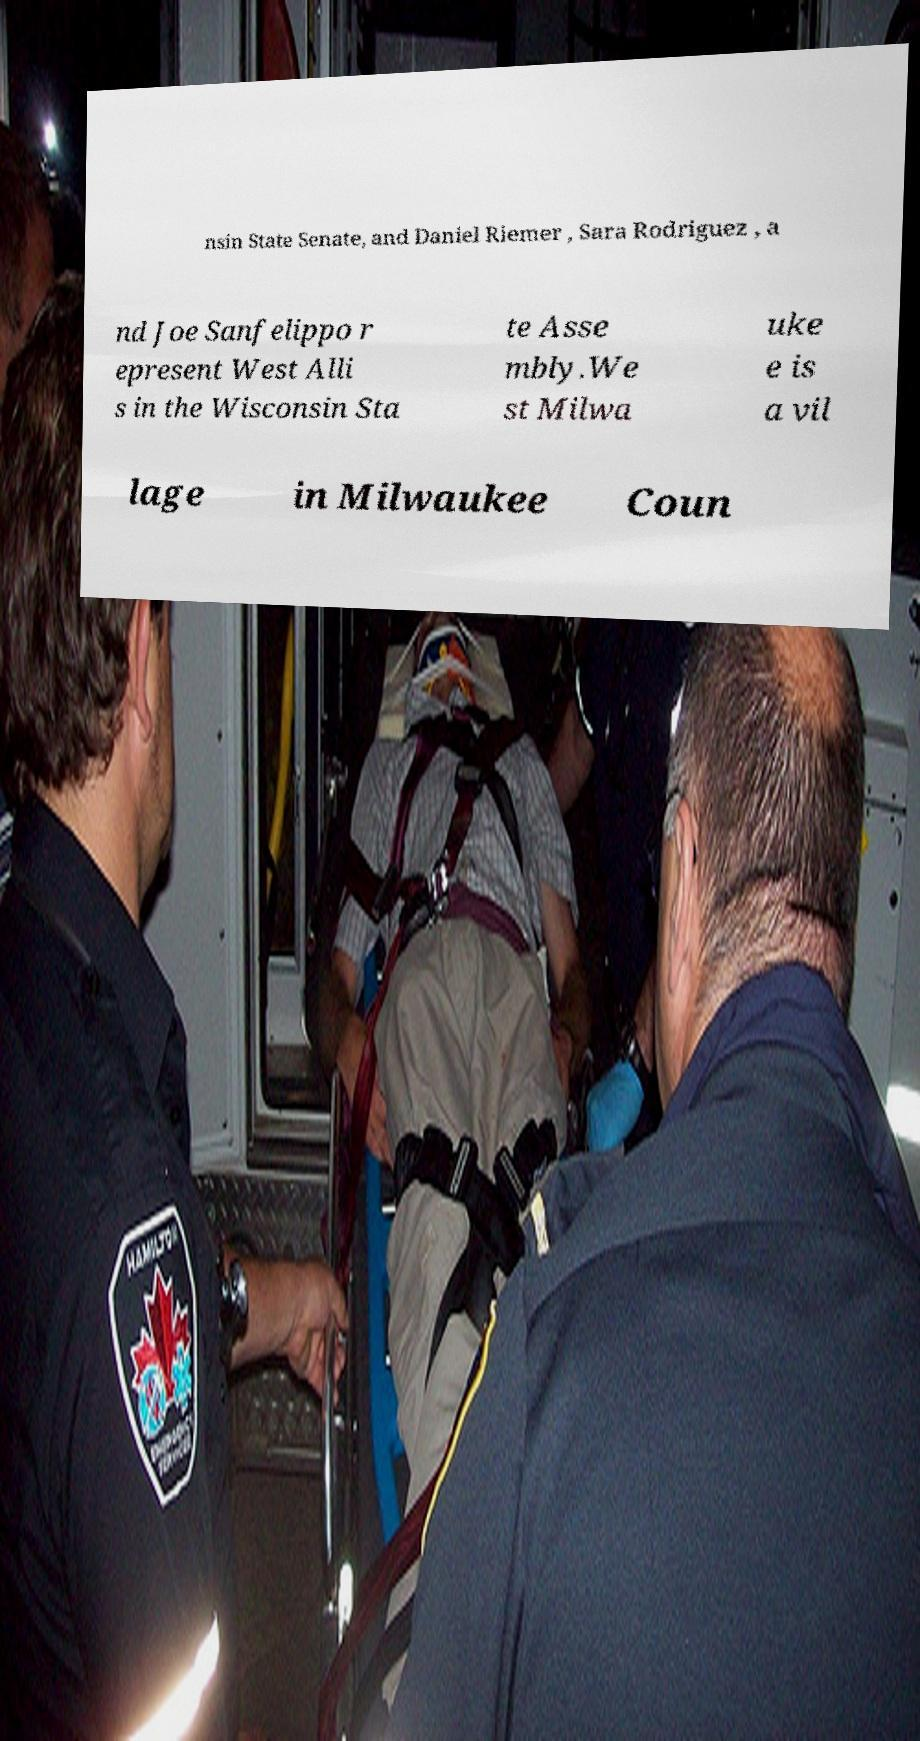What messages or text are displayed in this image? I need them in a readable, typed format. nsin State Senate, and Daniel Riemer , Sara Rodriguez , a nd Joe Sanfelippo r epresent West Alli s in the Wisconsin Sta te Asse mbly.We st Milwa uke e is a vil lage in Milwaukee Coun 